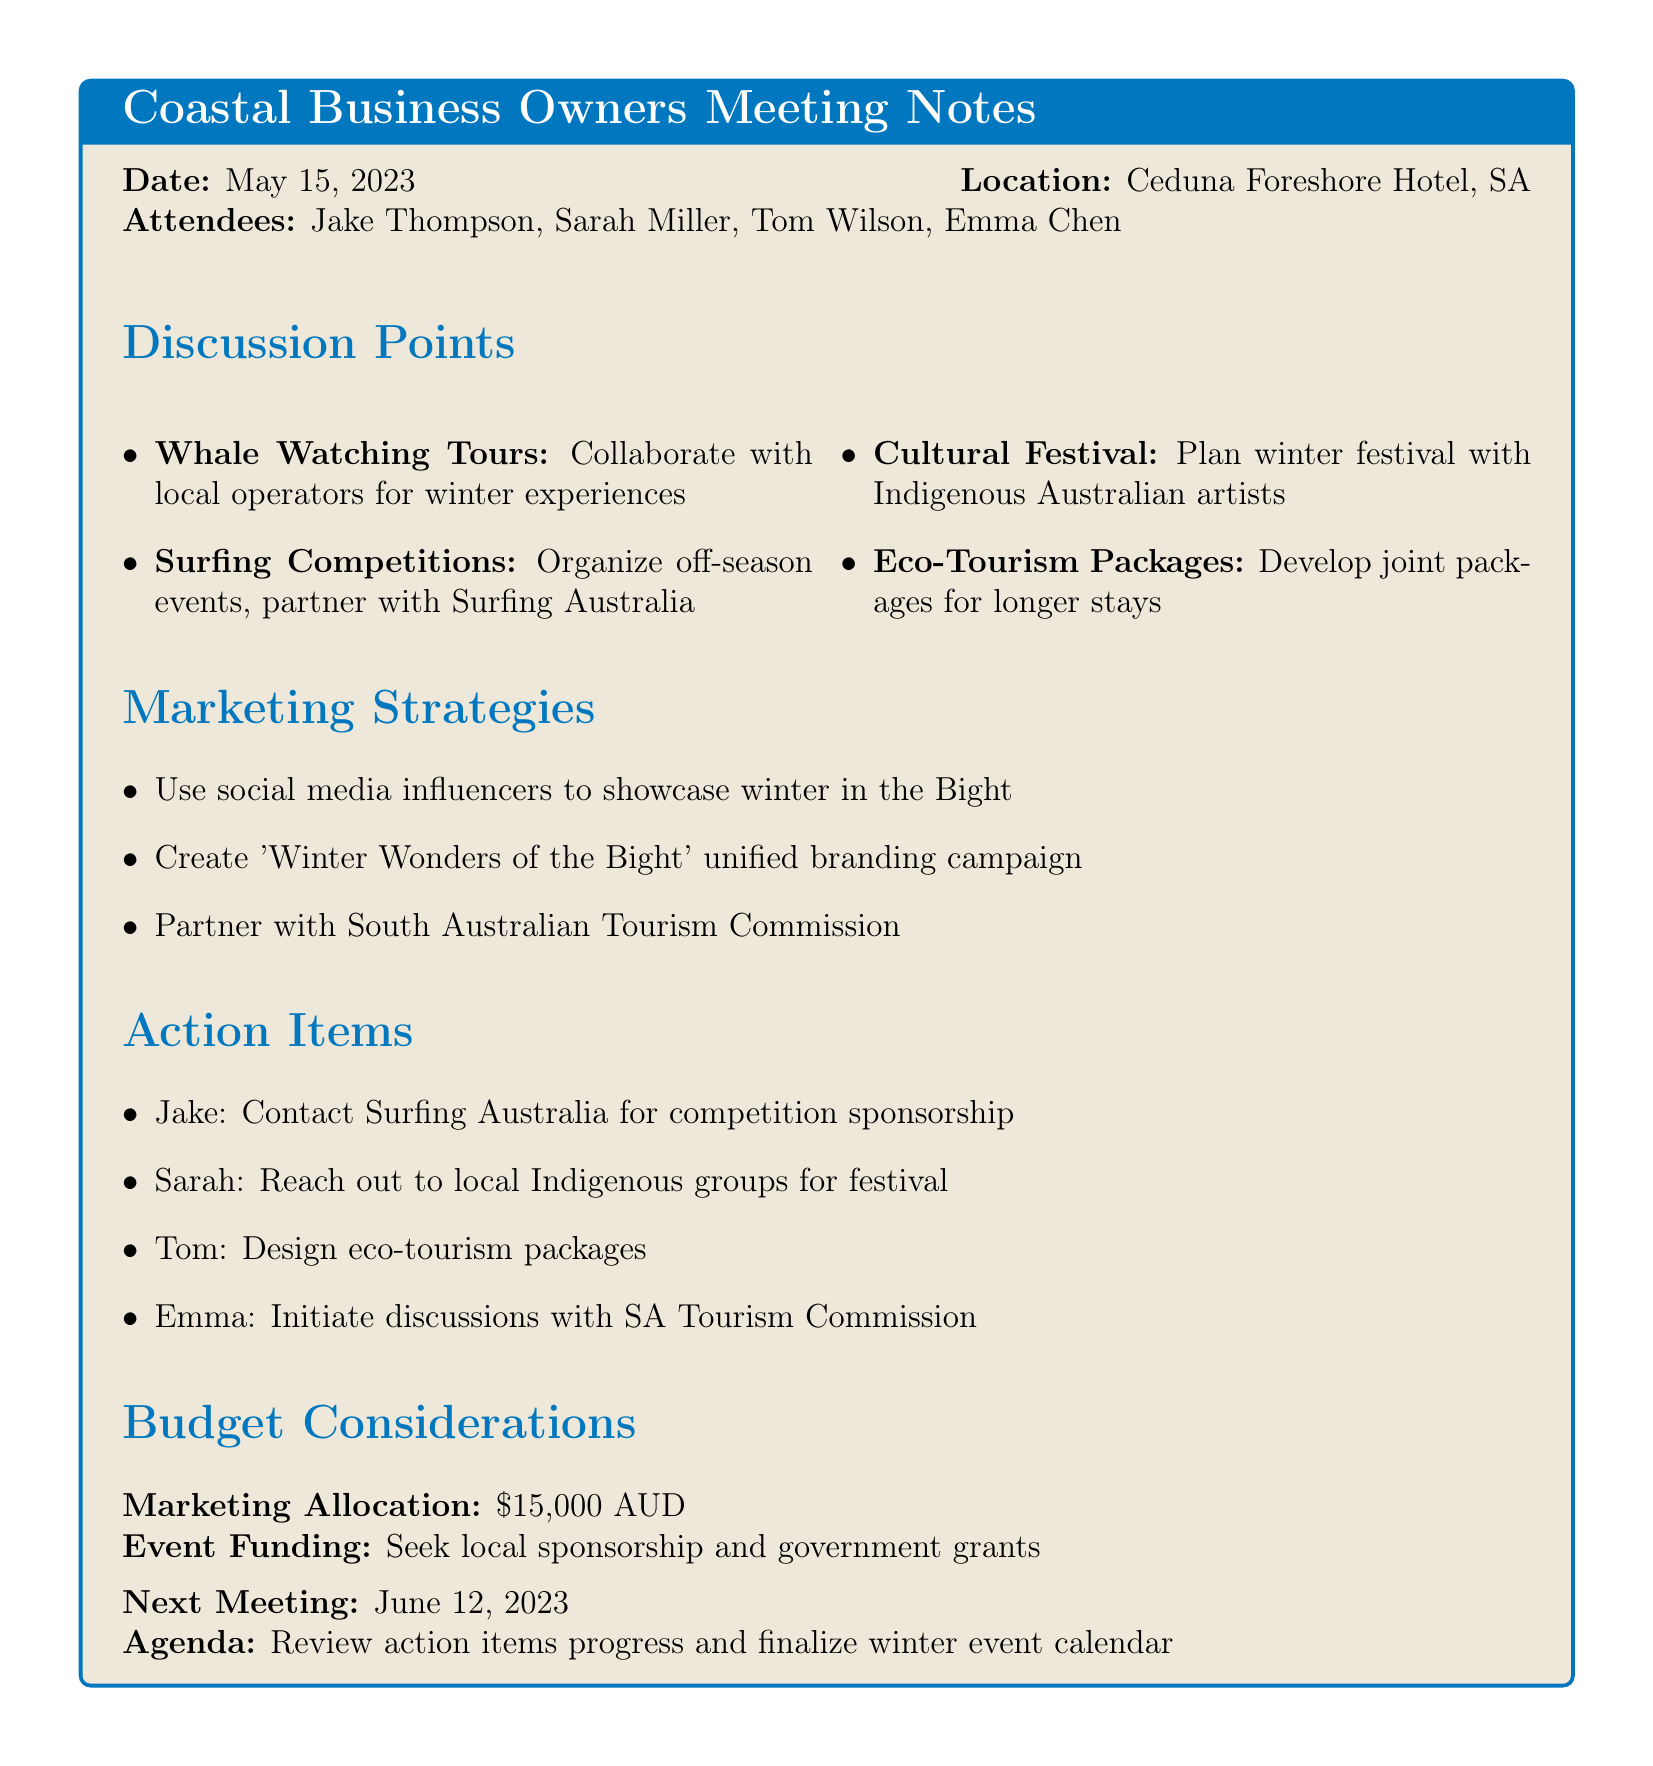What is the date of the meeting? The date of the meeting is mentioned clearly in the document.
Answer: May 15, 2023 Who is the owner of the seafood restaurant? The document lists the attendees of the meeting, including their titles.
Answer: Sarah Miller What is the budget allocation for marketing? The document specifies the amount allocated for marketing purposes.
Answer: $15,000 AUD What event is Jake responsible for contacting regarding sponsorship? The action items indicate specific tasks assigned to each attendee, including Jake's task.
Answer: Surfing Australia What is one of the marketing strategies discussed? The marketing strategies are listed in the document, reflecting collective goals.
Answer: Use social media influencers Which cultural group is involved in the proposed festival? The discussion points mention the participation of local artistic groups for the festival.
Answer: Indigenous Australian artists When is the next meeting scheduled? The document provides details about the next meeting date.
Answer: June 12, 2023 What is one objective for developing eco-tourism packages? The document outlines a goal for eco-tourism packages in relation to tourist stays.
Answer: Encourage longer stays What is the location of the meeting? The document includes details about where the meeting was held.
Answer: Ceduna Foreshore Hotel, South Australia 